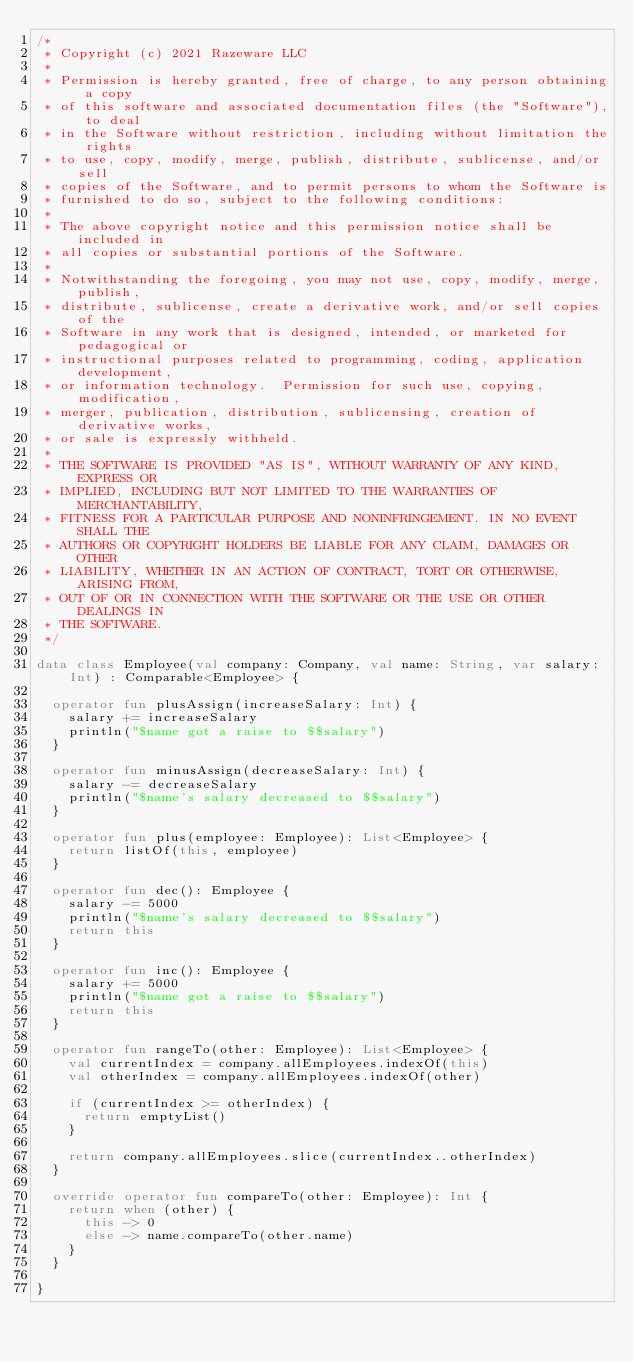<code> <loc_0><loc_0><loc_500><loc_500><_Kotlin_>/*
 * Copyright (c) 2021 Razeware LLC
 *
 * Permission is hereby granted, free of charge, to any person obtaining a copy
 * of this software and associated documentation files (the "Software"), to deal
 * in the Software without restriction, including without limitation the rights
 * to use, copy, modify, merge, publish, distribute, sublicense, and/or sell
 * copies of the Software, and to permit persons to whom the Software is
 * furnished to do so, subject to the following conditions:
 *
 * The above copyright notice and this permission notice shall be included in
 * all copies or substantial portions of the Software.
 *
 * Notwithstanding the foregoing, you may not use, copy, modify, merge, publish,
 * distribute, sublicense, create a derivative work, and/or sell copies of the
 * Software in any work that is designed, intended, or marketed for pedagogical or
 * instructional purposes related to programming, coding, application development,
 * or information technology.  Permission for such use, copying, modification,
 * merger, publication, distribution, sublicensing, creation of derivative works,
 * or sale is expressly withheld.
 *
 * THE SOFTWARE IS PROVIDED "AS IS", WITHOUT WARRANTY OF ANY KIND, EXPRESS OR
 * IMPLIED, INCLUDING BUT NOT LIMITED TO THE WARRANTIES OF MERCHANTABILITY,
 * FITNESS FOR A PARTICULAR PURPOSE AND NONINFRINGEMENT. IN NO EVENT SHALL THE
 * AUTHORS OR COPYRIGHT HOLDERS BE LIABLE FOR ANY CLAIM, DAMAGES OR OTHER
 * LIABILITY, WHETHER IN AN ACTION OF CONTRACT, TORT OR OTHERWISE, ARISING FROM,
 * OUT OF OR IN CONNECTION WITH THE SOFTWARE OR THE USE OR OTHER DEALINGS IN
 * THE SOFTWARE.
 */

data class Employee(val company: Company, val name: String, var salary: Int) : Comparable<Employee> {

  operator fun plusAssign(increaseSalary: Int) {
    salary += increaseSalary
    println("$name got a raise to $$salary")
  }

  operator fun minusAssign(decreaseSalary: Int) {
    salary -= decreaseSalary
    println("$name's salary decreased to $$salary")
  }

  operator fun plus(employee: Employee): List<Employee> {
    return listOf(this, employee)
  }

  operator fun dec(): Employee {
    salary -= 5000
    println("$name's salary decreased to $$salary")
    return this
  }

  operator fun inc(): Employee {
    salary += 5000
    println("$name got a raise to $$salary")
    return this
  }

  operator fun rangeTo(other: Employee): List<Employee> {
    val currentIndex = company.allEmployees.indexOf(this)
    val otherIndex = company.allEmployees.indexOf(other)

    if (currentIndex >= otherIndex) {
      return emptyList()
    }

    return company.allEmployees.slice(currentIndex..otherIndex)
  }

  override operator fun compareTo(other: Employee): Int {
    return when (other) {
      this -> 0
      else -> name.compareTo(other.name)
    }
  }

}
</code> 